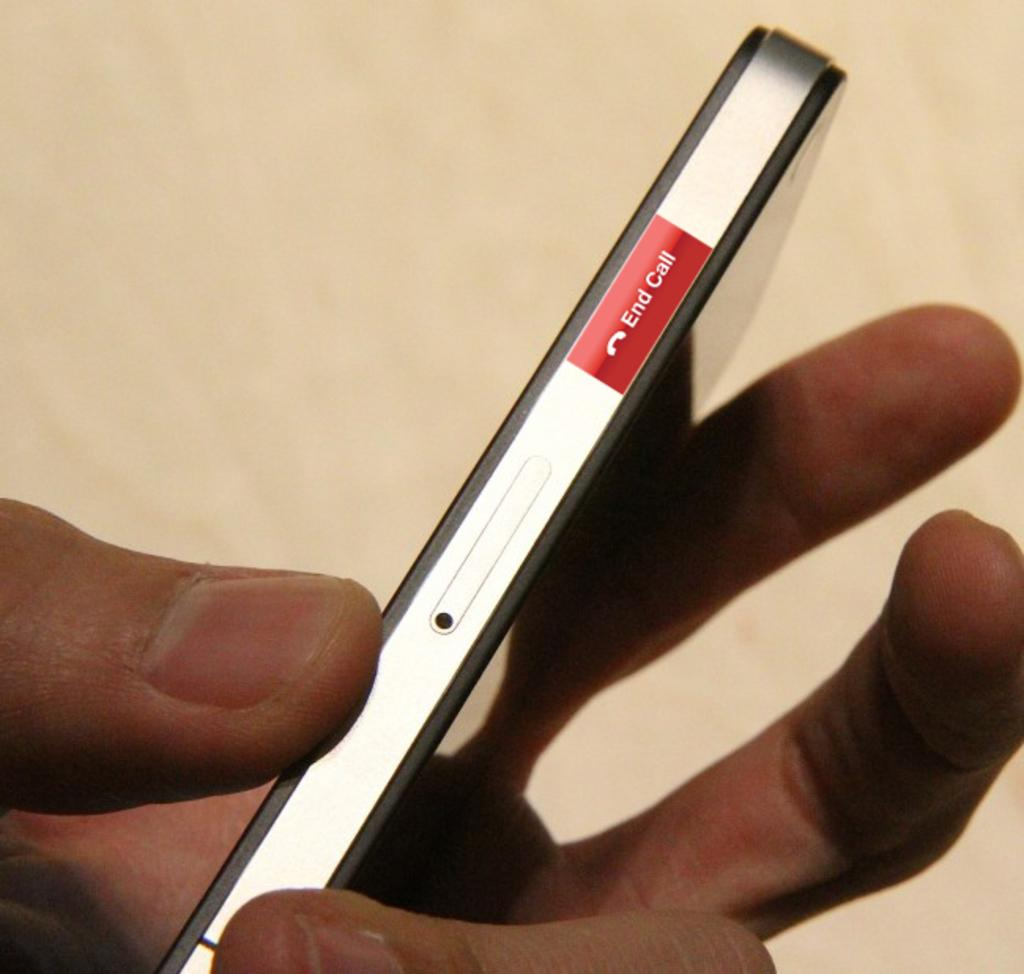<image>
Give a short and clear explanation of the subsequent image. a hand holding a cell phone with an end call button on the side 